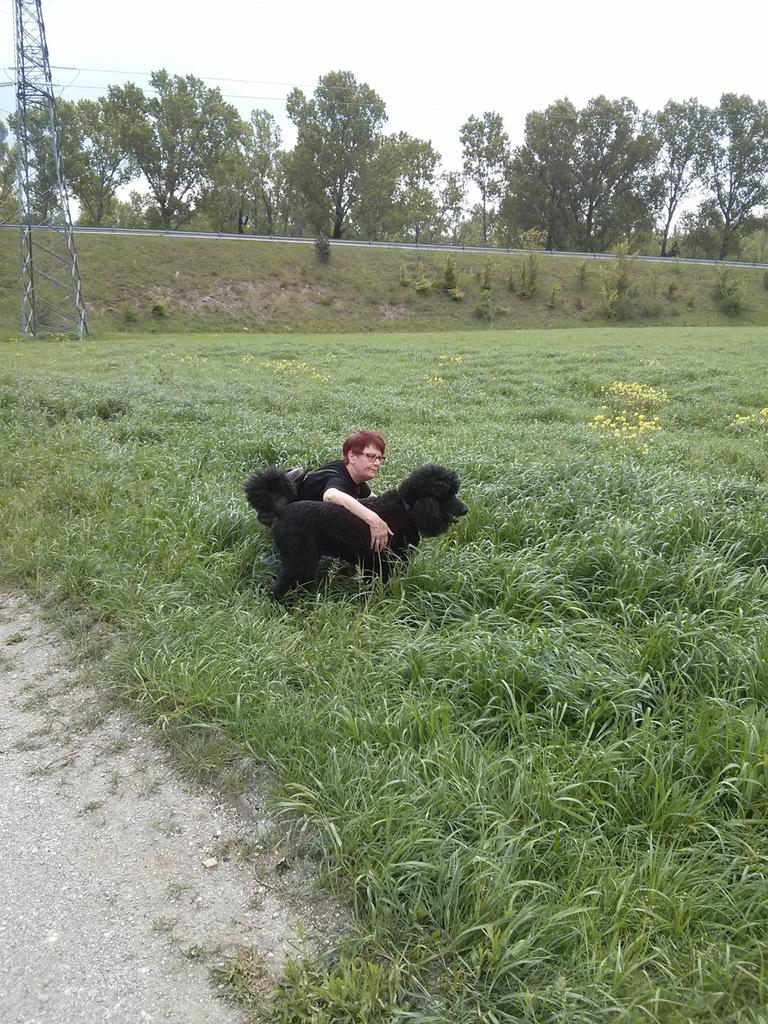Who or what can be seen in the image? There is a person and a dog in the image. What type of environment is depicted in the image? The image shows a grassy area with plants, flowers, and trees in the background. What structures or objects can be seen in the background? There is a tower, plants, grass, a fence, and trees in the background. What is visible in the sky in the background? There are clouds in the sky in the background. How many eggs are being used as a seat for the person in the image? There are no eggs present in the image; the person is standing or sitting on the grass. What type of balls can be seen bouncing around in the image? There are no balls present in the image; the focus is on the person, the dog, and the surrounding environment. 